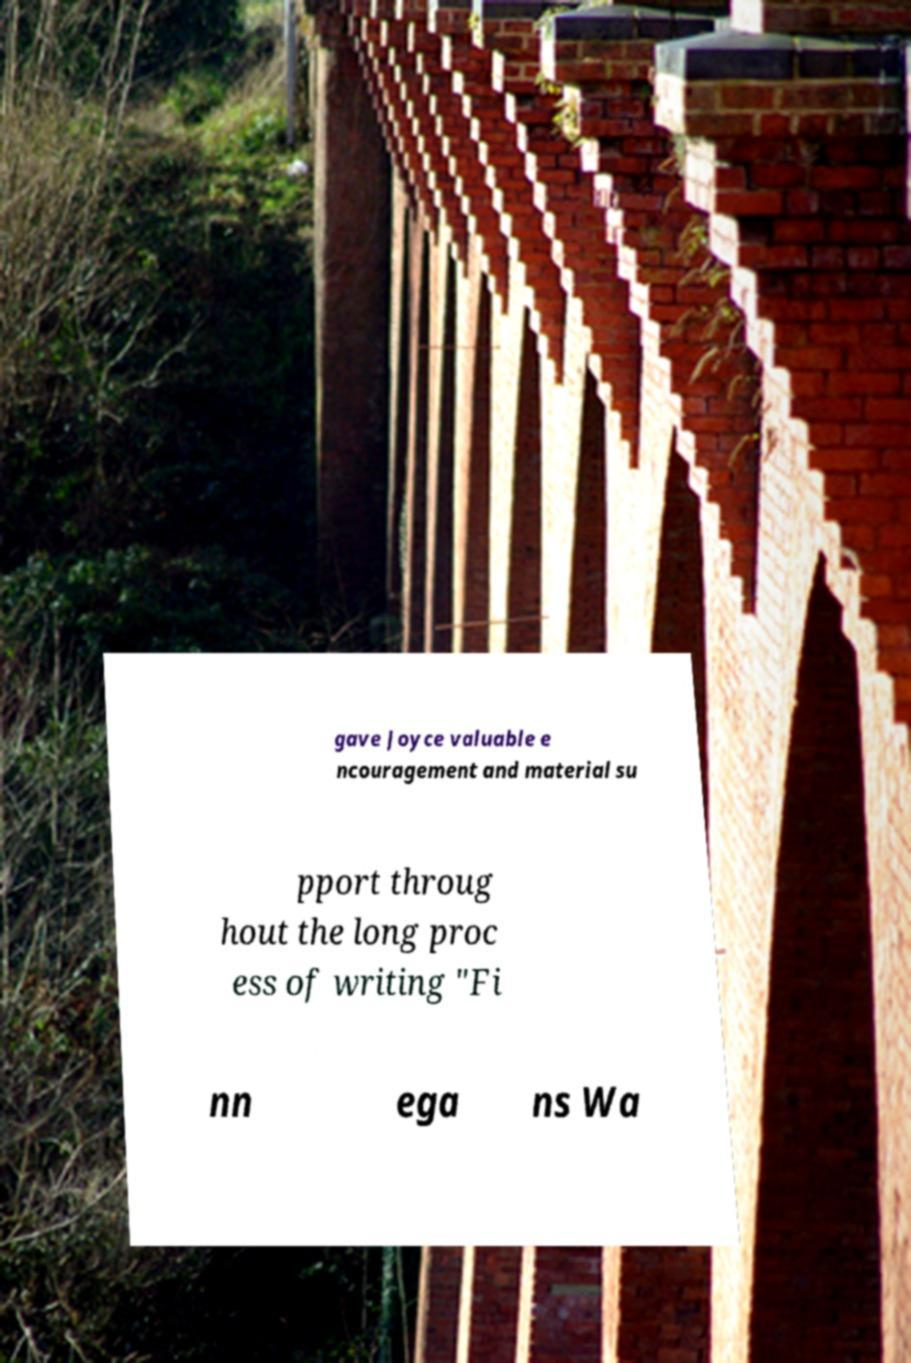Can you read and provide the text displayed in the image?This photo seems to have some interesting text. Can you extract and type it out for me? gave Joyce valuable e ncouragement and material su pport throug hout the long proc ess of writing "Fi nn ega ns Wa 